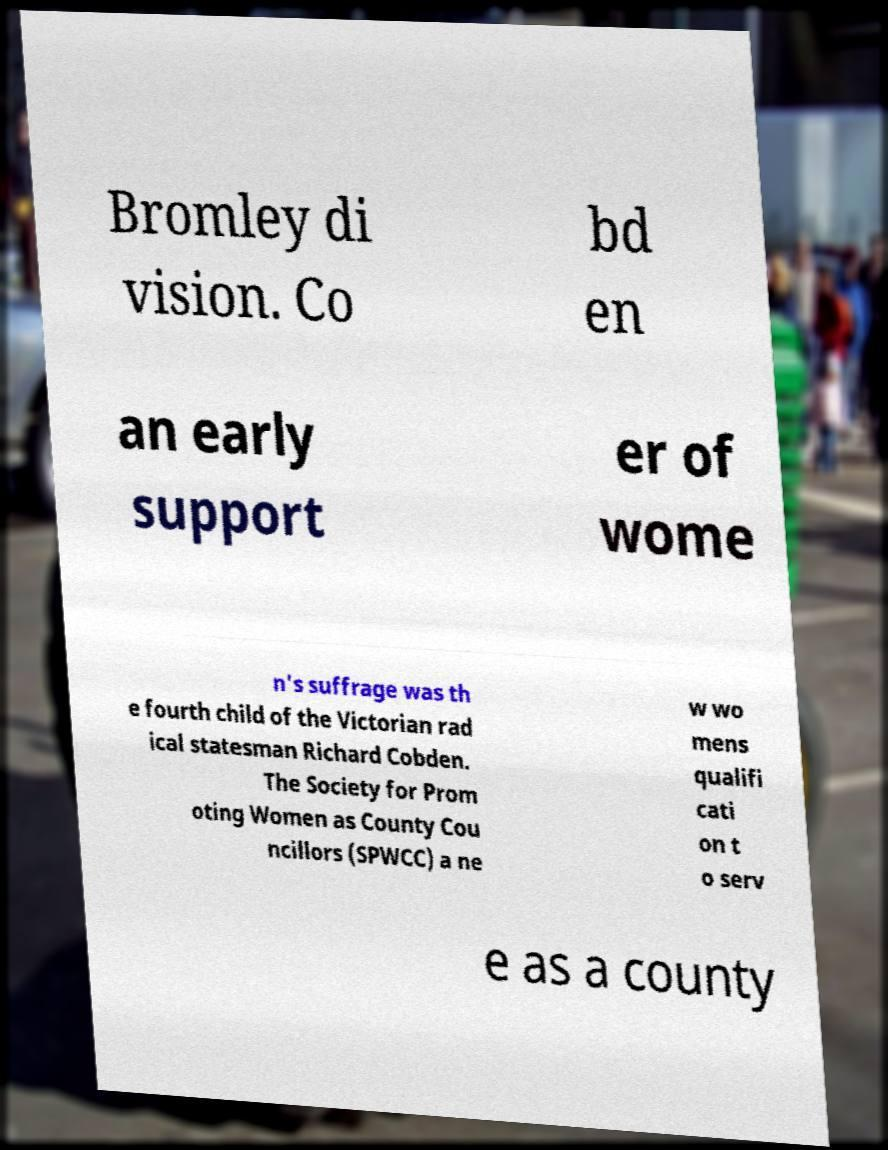For documentation purposes, I need the text within this image transcribed. Could you provide that? Bromley di vision. Co bd en an early support er of wome n's suffrage was th e fourth child of the Victorian rad ical statesman Richard Cobden. The Society for Prom oting Women as County Cou ncillors (SPWCC) a ne w wo mens qualifi cati on t o serv e as a county 